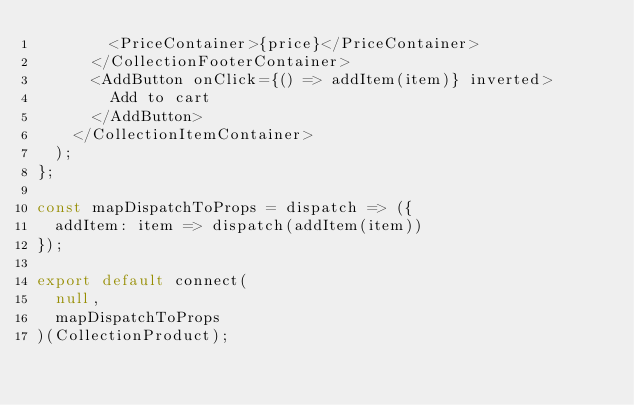Convert code to text. <code><loc_0><loc_0><loc_500><loc_500><_JavaScript_>        <PriceContainer>{price}</PriceContainer>
      </CollectionFooterContainer>
      <AddButton onClick={() => addItem(item)} inverted>
        Add to cart
      </AddButton>
    </CollectionItemContainer>
  );
};

const mapDispatchToProps = dispatch => ({
  addItem: item => dispatch(addItem(item))
});

export default connect(
  null,
  mapDispatchToProps
)(CollectionProduct);
</code> 